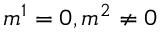Convert formula to latex. <formula><loc_0><loc_0><loc_500><loc_500>m ^ { 1 } = 0 , m ^ { 2 } \neq 0</formula> 